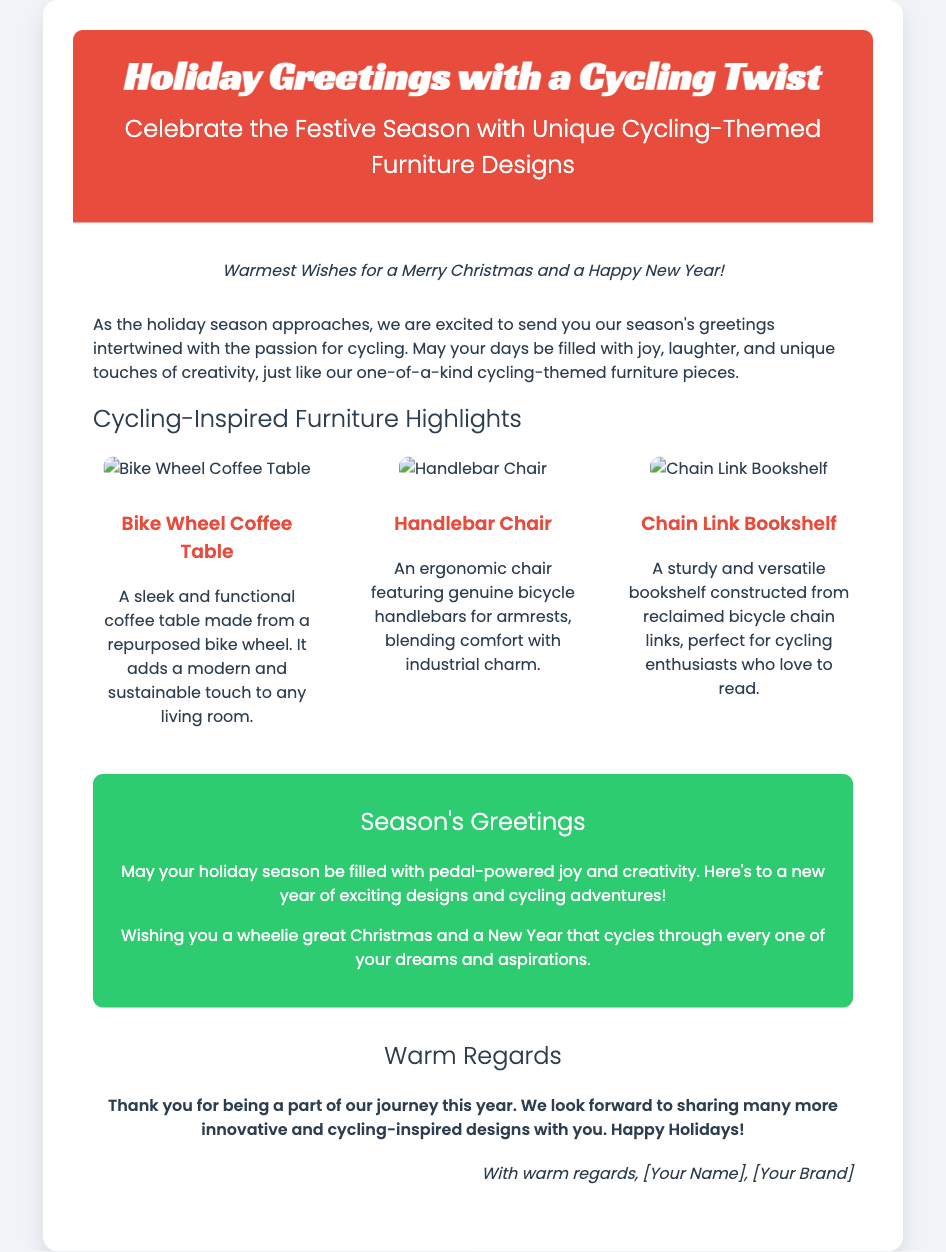What is the title of the card? The title of the card is presented prominently at the top of the document.
Answer: Holiday Greetings with a Cycling Twist Who are the greetings intended for? The greetings are meant for recipients during the holiday season, wishing them well.
Answer: Season's Greetings What unique furniture item is highlighted as a coffee table? The document lists specific cycling-themed furniture items, including one made from bike components.
Answer: Bike Wheel Coffee Table What color is the background of the card? The card's background color is specified in the style section of the document.
Answer: #f0f4f8 How many furniture items are showcased? Observing the content area, we can count the number of furniture highlights mentioned.
Answer: Three What is the closing message's header? The header for the closing section is defined as a main heading.
Answer: Warm Regards What is the purpose of the card? The primary purpose of the card is stated within its content, focusing on seasonal greetings and unique designs.
Answer: To send season's greetings and showcase designs Which two holidays are mentioned in the card? The card includes greetings for specific festive occasions that occur during the holiday season.
Answer: Christmas and New Year 